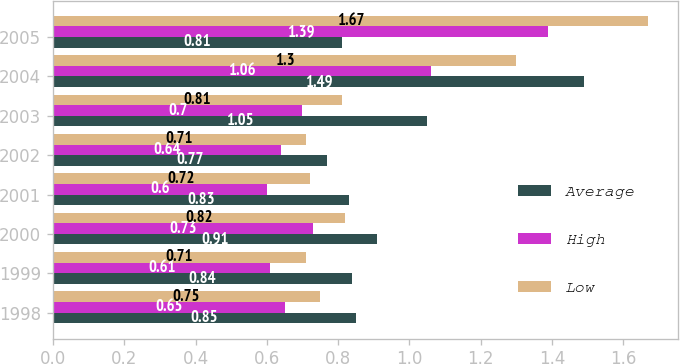Convert chart to OTSL. <chart><loc_0><loc_0><loc_500><loc_500><stacked_bar_chart><ecel><fcel>1998<fcel>1999<fcel>2000<fcel>2001<fcel>2002<fcel>2003<fcel>2004<fcel>2005<nl><fcel>Average<fcel>0.85<fcel>0.84<fcel>0.91<fcel>0.83<fcel>0.77<fcel>1.05<fcel>1.49<fcel>0.81<nl><fcel>High<fcel>0.65<fcel>0.61<fcel>0.73<fcel>0.6<fcel>0.64<fcel>0.7<fcel>1.06<fcel>1.39<nl><fcel>Low<fcel>0.75<fcel>0.71<fcel>0.82<fcel>0.72<fcel>0.71<fcel>0.81<fcel>1.3<fcel>1.67<nl></chart> 